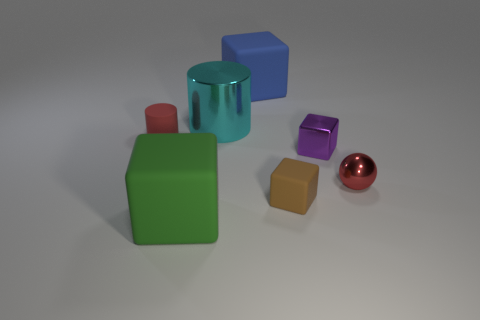Subtract 1 blocks. How many blocks are left? 3 Add 2 small red rubber objects. How many objects exist? 9 Subtract all cubes. How many objects are left? 3 Add 3 large green cubes. How many large green cubes are left? 4 Add 6 large blue rubber blocks. How many large blue rubber blocks exist? 7 Subtract 0 gray cubes. How many objects are left? 7 Subtract all tiny purple objects. Subtract all big blue objects. How many objects are left? 5 